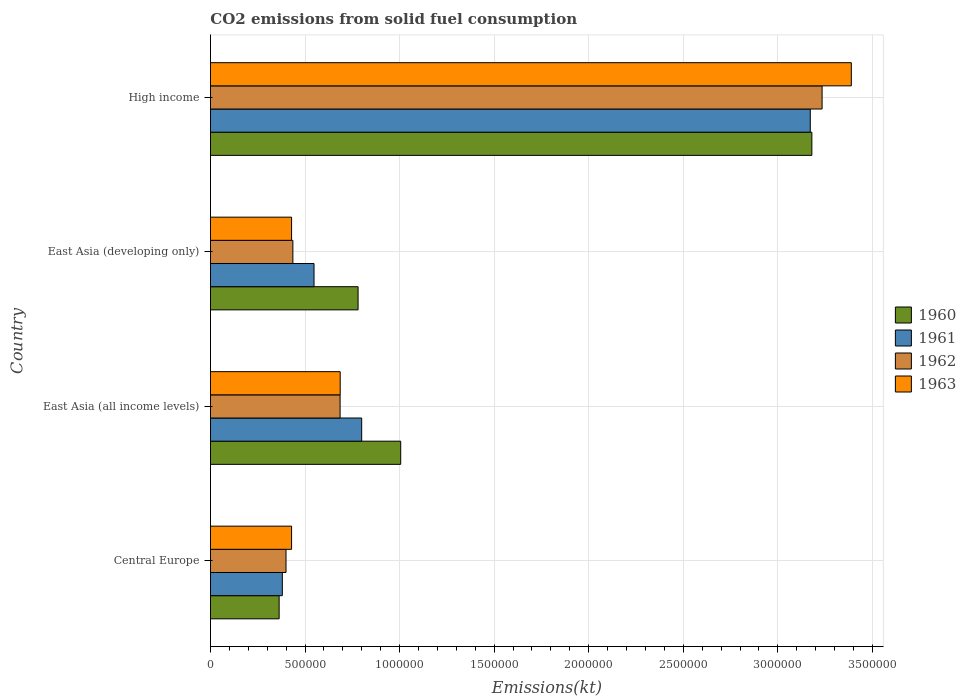Are the number of bars on each tick of the Y-axis equal?
Offer a very short reply. Yes. How many bars are there on the 4th tick from the bottom?
Provide a short and direct response. 4. What is the label of the 1st group of bars from the top?
Provide a short and direct response. High income. What is the amount of CO2 emitted in 1961 in Central Europe?
Provide a succinct answer. 3.80e+05. Across all countries, what is the maximum amount of CO2 emitted in 1961?
Your answer should be very brief. 3.17e+06. Across all countries, what is the minimum amount of CO2 emitted in 1963?
Offer a very short reply. 4.29e+05. In which country was the amount of CO2 emitted in 1960 minimum?
Your response must be concise. Central Europe. What is the total amount of CO2 emitted in 1963 in the graph?
Make the answer very short. 4.93e+06. What is the difference between the amount of CO2 emitted in 1961 in Central Europe and that in East Asia (developing only)?
Your response must be concise. -1.68e+05. What is the difference between the amount of CO2 emitted in 1961 in Central Europe and the amount of CO2 emitted in 1963 in East Asia (all income levels)?
Your response must be concise. -3.06e+05. What is the average amount of CO2 emitted in 1961 per country?
Your answer should be very brief. 1.22e+06. What is the difference between the amount of CO2 emitted in 1963 and amount of CO2 emitted in 1960 in High income?
Offer a terse response. 2.09e+05. What is the ratio of the amount of CO2 emitted in 1961 in Central Europe to that in East Asia (developing only)?
Ensure brevity in your answer.  0.69. Is the difference between the amount of CO2 emitted in 1963 in East Asia (all income levels) and High income greater than the difference between the amount of CO2 emitted in 1960 in East Asia (all income levels) and High income?
Offer a terse response. No. What is the difference between the highest and the second highest amount of CO2 emitted in 1962?
Provide a succinct answer. 2.55e+06. What is the difference between the highest and the lowest amount of CO2 emitted in 1960?
Provide a succinct answer. 2.82e+06. Is it the case that in every country, the sum of the amount of CO2 emitted in 1962 and amount of CO2 emitted in 1963 is greater than the sum of amount of CO2 emitted in 1960 and amount of CO2 emitted in 1961?
Your response must be concise. No. How many bars are there?
Provide a succinct answer. 16. How many countries are there in the graph?
Provide a short and direct response. 4. Does the graph contain grids?
Offer a terse response. Yes. How many legend labels are there?
Provide a short and direct response. 4. What is the title of the graph?
Provide a short and direct response. CO2 emissions from solid fuel consumption. Does "2004" appear as one of the legend labels in the graph?
Ensure brevity in your answer.  No. What is the label or title of the X-axis?
Provide a short and direct response. Emissions(kt). What is the label or title of the Y-axis?
Offer a very short reply. Country. What is the Emissions(kt) of 1960 in Central Europe?
Make the answer very short. 3.63e+05. What is the Emissions(kt) of 1961 in Central Europe?
Your answer should be compact. 3.80e+05. What is the Emissions(kt) in 1962 in Central Europe?
Your answer should be very brief. 3.99e+05. What is the Emissions(kt) of 1963 in Central Europe?
Ensure brevity in your answer.  4.29e+05. What is the Emissions(kt) of 1960 in East Asia (all income levels)?
Your answer should be compact. 1.01e+06. What is the Emissions(kt) of 1961 in East Asia (all income levels)?
Your answer should be compact. 8.00e+05. What is the Emissions(kt) in 1962 in East Asia (all income levels)?
Give a very brief answer. 6.85e+05. What is the Emissions(kt) of 1963 in East Asia (all income levels)?
Your answer should be very brief. 6.86e+05. What is the Emissions(kt) in 1960 in East Asia (developing only)?
Give a very brief answer. 7.80e+05. What is the Emissions(kt) in 1961 in East Asia (developing only)?
Your answer should be very brief. 5.48e+05. What is the Emissions(kt) of 1962 in East Asia (developing only)?
Offer a terse response. 4.36e+05. What is the Emissions(kt) in 1963 in East Asia (developing only)?
Your answer should be very brief. 4.29e+05. What is the Emissions(kt) in 1960 in High income?
Keep it short and to the point. 3.18e+06. What is the Emissions(kt) of 1961 in High income?
Provide a succinct answer. 3.17e+06. What is the Emissions(kt) of 1962 in High income?
Make the answer very short. 3.23e+06. What is the Emissions(kt) of 1963 in High income?
Keep it short and to the point. 3.39e+06. Across all countries, what is the maximum Emissions(kt) of 1960?
Give a very brief answer. 3.18e+06. Across all countries, what is the maximum Emissions(kt) in 1961?
Provide a succinct answer. 3.17e+06. Across all countries, what is the maximum Emissions(kt) of 1962?
Ensure brevity in your answer.  3.23e+06. Across all countries, what is the maximum Emissions(kt) of 1963?
Give a very brief answer. 3.39e+06. Across all countries, what is the minimum Emissions(kt) of 1960?
Your answer should be very brief. 3.63e+05. Across all countries, what is the minimum Emissions(kt) in 1961?
Provide a succinct answer. 3.80e+05. Across all countries, what is the minimum Emissions(kt) in 1962?
Make the answer very short. 3.99e+05. Across all countries, what is the minimum Emissions(kt) in 1963?
Your answer should be very brief. 4.29e+05. What is the total Emissions(kt) of 1960 in the graph?
Give a very brief answer. 5.33e+06. What is the total Emissions(kt) in 1961 in the graph?
Your answer should be compact. 4.90e+06. What is the total Emissions(kt) in 1962 in the graph?
Ensure brevity in your answer.  4.75e+06. What is the total Emissions(kt) in 1963 in the graph?
Ensure brevity in your answer.  4.93e+06. What is the difference between the Emissions(kt) in 1960 in Central Europe and that in East Asia (all income levels)?
Your answer should be very brief. -6.43e+05. What is the difference between the Emissions(kt) of 1961 in Central Europe and that in East Asia (all income levels)?
Offer a very short reply. -4.20e+05. What is the difference between the Emissions(kt) of 1962 in Central Europe and that in East Asia (all income levels)?
Ensure brevity in your answer.  -2.86e+05. What is the difference between the Emissions(kt) of 1963 in Central Europe and that in East Asia (all income levels)?
Make the answer very short. -2.57e+05. What is the difference between the Emissions(kt) in 1960 in Central Europe and that in East Asia (developing only)?
Ensure brevity in your answer.  -4.17e+05. What is the difference between the Emissions(kt) in 1961 in Central Europe and that in East Asia (developing only)?
Keep it short and to the point. -1.68e+05. What is the difference between the Emissions(kt) of 1962 in Central Europe and that in East Asia (developing only)?
Give a very brief answer. -3.63e+04. What is the difference between the Emissions(kt) of 1963 in Central Europe and that in East Asia (developing only)?
Ensure brevity in your answer.  4.63. What is the difference between the Emissions(kt) of 1960 in Central Europe and that in High income?
Keep it short and to the point. -2.82e+06. What is the difference between the Emissions(kt) in 1961 in Central Europe and that in High income?
Ensure brevity in your answer.  -2.79e+06. What is the difference between the Emissions(kt) in 1962 in Central Europe and that in High income?
Make the answer very short. -2.83e+06. What is the difference between the Emissions(kt) of 1963 in Central Europe and that in High income?
Offer a terse response. -2.96e+06. What is the difference between the Emissions(kt) in 1960 in East Asia (all income levels) and that in East Asia (developing only)?
Provide a succinct answer. 2.25e+05. What is the difference between the Emissions(kt) in 1961 in East Asia (all income levels) and that in East Asia (developing only)?
Your answer should be compact. 2.52e+05. What is the difference between the Emissions(kt) in 1962 in East Asia (all income levels) and that in East Asia (developing only)?
Provide a succinct answer. 2.50e+05. What is the difference between the Emissions(kt) of 1963 in East Asia (all income levels) and that in East Asia (developing only)?
Provide a short and direct response. 2.57e+05. What is the difference between the Emissions(kt) of 1960 in East Asia (all income levels) and that in High income?
Keep it short and to the point. -2.17e+06. What is the difference between the Emissions(kt) of 1961 in East Asia (all income levels) and that in High income?
Give a very brief answer. -2.37e+06. What is the difference between the Emissions(kt) in 1962 in East Asia (all income levels) and that in High income?
Give a very brief answer. -2.55e+06. What is the difference between the Emissions(kt) in 1963 in East Asia (all income levels) and that in High income?
Provide a short and direct response. -2.70e+06. What is the difference between the Emissions(kt) in 1960 in East Asia (developing only) and that in High income?
Provide a short and direct response. -2.40e+06. What is the difference between the Emissions(kt) in 1961 in East Asia (developing only) and that in High income?
Offer a very short reply. -2.62e+06. What is the difference between the Emissions(kt) of 1962 in East Asia (developing only) and that in High income?
Your response must be concise. -2.80e+06. What is the difference between the Emissions(kt) in 1963 in East Asia (developing only) and that in High income?
Ensure brevity in your answer.  -2.96e+06. What is the difference between the Emissions(kt) of 1960 in Central Europe and the Emissions(kt) of 1961 in East Asia (all income levels)?
Make the answer very short. -4.36e+05. What is the difference between the Emissions(kt) in 1960 in Central Europe and the Emissions(kt) in 1962 in East Asia (all income levels)?
Make the answer very short. -3.22e+05. What is the difference between the Emissions(kt) in 1960 in Central Europe and the Emissions(kt) in 1963 in East Asia (all income levels)?
Your answer should be compact. -3.23e+05. What is the difference between the Emissions(kt) in 1961 in Central Europe and the Emissions(kt) in 1962 in East Asia (all income levels)?
Give a very brief answer. -3.05e+05. What is the difference between the Emissions(kt) in 1961 in Central Europe and the Emissions(kt) in 1963 in East Asia (all income levels)?
Offer a terse response. -3.06e+05. What is the difference between the Emissions(kt) of 1962 in Central Europe and the Emissions(kt) of 1963 in East Asia (all income levels)?
Provide a succinct answer. -2.86e+05. What is the difference between the Emissions(kt) in 1960 in Central Europe and the Emissions(kt) in 1961 in East Asia (developing only)?
Provide a succinct answer. -1.84e+05. What is the difference between the Emissions(kt) of 1960 in Central Europe and the Emissions(kt) of 1962 in East Asia (developing only)?
Your answer should be compact. -7.27e+04. What is the difference between the Emissions(kt) of 1960 in Central Europe and the Emissions(kt) of 1963 in East Asia (developing only)?
Provide a short and direct response. -6.58e+04. What is the difference between the Emissions(kt) of 1961 in Central Europe and the Emissions(kt) of 1962 in East Asia (developing only)?
Provide a short and direct response. -5.58e+04. What is the difference between the Emissions(kt) in 1961 in Central Europe and the Emissions(kt) in 1963 in East Asia (developing only)?
Your answer should be very brief. -4.89e+04. What is the difference between the Emissions(kt) of 1962 in Central Europe and the Emissions(kt) of 1963 in East Asia (developing only)?
Offer a terse response. -2.94e+04. What is the difference between the Emissions(kt) in 1960 in Central Europe and the Emissions(kt) in 1961 in High income?
Offer a terse response. -2.81e+06. What is the difference between the Emissions(kt) in 1960 in Central Europe and the Emissions(kt) in 1962 in High income?
Provide a succinct answer. -2.87e+06. What is the difference between the Emissions(kt) of 1960 in Central Europe and the Emissions(kt) of 1963 in High income?
Ensure brevity in your answer.  -3.03e+06. What is the difference between the Emissions(kt) in 1961 in Central Europe and the Emissions(kt) in 1962 in High income?
Offer a terse response. -2.85e+06. What is the difference between the Emissions(kt) in 1961 in Central Europe and the Emissions(kt) in 1963 in High income?
Your answer should be very brief. -3.01e+06. What is the difference between the Emissions(kt) in 1962 in Central Europe and the Emissions(kt) in 1963 in High income?
Your response must be concise. -2.99e+06. What is the difference between the Emissions(kt) in 1960 in East Asia (all income levels) and the Emissions(kt) in 1961 in East Asia (developing only)?
Your answer should be compact. 4.58e+05. What is the difference between the Emissions(kt) in 1960 in East Asia (all income levels) and the Emissions(kt) in 1962 in East Asia (developing only)?
Your response must be concise. 5.70e+05. What is the difference between the Emissions(kt) of 1960 in East Asia (all income levels) and the Emissions(kt) of 1963 in East Asia (developing only)?
Ensure brevity in your answer.  5.77e+05. What is the difference between the Emissions(kt) in 1961 in East Asia (all income levels) and the Emissions(kt) in 1962 in East Asia (developing only)?
Keep it short and to the point. 3.64e+05. What is the difference between the Emissions(kt) in 1961 in East Asia (all income levels) and the Emissions(kt) in 1963 in East Asia (developing only)?
Offer a terse response. 3.71e+05. What is the difference between the Emissions(kt) in 1962 in East Asia (all income levels) and the Emissions(kt) in 1963 in East Asia (developing only)?
Give a very brief answer. 2.57e+05. What is the difference between the Emissions(kt) of 1960 in East Asia (all income levels) and the Emissions(kt) of 1961 in High income?
Offer a terse response. -2.17e+06. What is the difference between the Emissions(kt) of 1960 in East Asia (all income levels) and the Emissions(kt) of 1962 in High income?
Your answer should be compact. -2.23e+06. What is the difference between the Emissions(kt) of 1960 in East Asia (all income levels) and the Emissions(kt) of 1963 in High income?
Your answer should be compact. -2.38e+06. What is the difference between the Emissions(kt) in 1961 in East Asia (all income levels) and the Emissions(kt) in 1962 in High income?
Keep it short and to the point. -2.43e+06. What is the difference between the Emissions(kt) in 1961 in East Asia (all income levels) and the Emissions(kt) in 1963 in High income?
Make the answer very short. -2.59e+06. What is the difference between the Emissions(kt) of 1962 in East Asia (all income levels) and the Emissions(kt) of 1963 in High income?
Your answer should be compact. -2.70e+06. What is the difference between the Emissions(kt) in 1960 in East Asia (developing only) and the Emissions(kt) in 1961 in High income?
Give a very brief answer. -2.39e+06. What is the difference between the Emissions(kt) in 1960 in East Asia (developing only) and the Emissions(kt) in 1962 in High income?
Your answer should be compact. -2.45e+06. What is the difference between the Emissions(kt) in 1960 in East Asia (developing only) and the Emissions(kt) in 1963 in High income?
Keep it short and to the point. -2.61e+06. What is the difference between the Emissions(kt) in 1961 in East Asia (developing only) and the Emissions(kt) in 1962 in High income?
Your answer should be compact. -2.69e+06. What is the difference between the Emissions(kt) of 1961 in East Asia (developing only) and the Emissions(kt) of 1963 in High income?
Your answer should be compact. -2.84e+06. What is the difference between the Emissions(kt) in 1962 in East Asia (developing only) and the Emissions(kt) in 1963 in High income?
Your answer should be very brief. -2.95e+06. What is the average Emissions(kt) of 1960 per country?
Ensure brevity in your answer.  1.33e+06. What is the average Emissions(kt) in 1961 per country?
Make the answer very short. 1.22e+06. What is the average Emissions(kt) in 1962 per country?
Give a very brief answer. 1.19e+06. What is the average Emissions(kt) of 1963 per country?
Make the answer very short. 1.23e+06. What is the difference between the Emissions(kt) in 1960 and Emissions(kt) in 1961 in Central Europe?
Provide a succinct answer. -1.68e+04. What is the difference between the Emissions(kt) of 1960 and Emissions(kt) of 1962 in Central Europe?
Provide a succinct answer. -3.64e+04. What is the difference between the Emissions(kt) of 1960 and Emissions(kt) of 1963 in Central Europe?
Offer a terse response. -6.58e+04. What is the difference between the Emissions(kt) in 1961 and Emissions(kt) in 1962 in Central Europe?
Keep it short and to the point. -1.96e+04. What is the difference between the Emissions(kt) of 1961 and Emissions(kt) of 1963 in Central Europe?
Your answer should be compact. -4.89e+04. What is the difference between the Emissions(kt) of 1962 and Emissions(kt) of 1963 in Central Europe?
Provide a short and direct response. -2.94e+04. What is the difference between the Emissions(kt) in 1960 and Emissions(kt) in 1961 in East Asia (all income levels)?
Give a very brief answer. 2.06e+05. What is the difference between the Emissions(kt) of 1960 and Emissions(kt) of 1962 in East Asia (all income levels)?
Your response must be concise. 3.20e+05. What is the difference between the Emissions(kt) in 1960 and Emissions(kt) in 1963 in East Asia (all income levels)?
Your response must be concise. 3.20e+05. What is the difference between the Emissions(kt) in 1961 and Emissions(kt) in 1962 in East Asia (all income levels)?
Provide a short and direct response. 1.14e+05. What is the difference between the Emissions(kt) in 1961 and Emissions(kt) in 1963 in East Asia (all income levels)?
Keep it short and to the point. 1.14e+05. What is the difference between the Emissions(kt) in 1962 and Emissions(kt) in 1963 in East Asia (all income levels)?
Your answer should be very brief. -517.54. What is the difference between the Emissions(kt) in 1960 and Emissions(kt) in 1961 in East Asia (developing only)?
Offer a terse response. 2.33e+05. What is the difference between the Emissions(kt) in 1960 and Emissions(kt) in 1962 in East Asia (developing only)?
Provide a short and direct response. 3.45e+05. What is the difference between the Emissions(kt) of 1960 and Emissions(kt) of 1963 in East Asia (developing only)?
Offer a very short reply. 3.52e+05. What is the difference between the Emissions(kt) of 1961 and Emissions(kt) of 1962 in East Asia (developing only)?
Your answer should be compact. 1.12e+05. What is the difference between the Emissions(kt) of 1961 and Emissions(kt) of 1963 in East Asia (developing only)?
Make the answer very short. 1.19e+05. What is the difference between the Emissions(kt) of 1962 and Emissions(kt) of 1963 in East Asia (developing only)?
Your answer should be very brief. 6890.94. What is the difference between the Emissions(kt) of 1960 and Emissions(kt) of 1961 in High income?
Your answer should be compact. 8354.42. What is the difference between the Emissions(kt) of 1960 and Emissions(kt) of 1962 in High income?
Keep it short and to the point. -5.41e+04. What is the difference between the Emissions(kt) in 1960 and Emissions(kt) in 1963 in High income?
Provide a succinct answer. -2.09e+05. What is the difference between the Emissions(kt) in 1961 and Emissions(kt) in 1962 in High income?
Give a very brief answer. -6.24e+04. What is the difference between the Emissions(kt) in 1961 and Emissions(kt) in 1963 in High income?
Ensure brevity in your answer.  -2.17e+05. What is the difference between the Emissions(kt) of 1962 and Emissions(kt) of 1963 in High income?
Offer a very short reply. -1.55e+05. What is the ratio of the Emissions(kt) of 1960 in Central Europe to that in East Asia (all income levels)?
Make the answer very short. 0.36. What is the ratio of the Emissions(kt) in 1961 in Central Europe to that in East Asia (all income levels)?
Provide a succinct answer. 0.48. What is the ratio of the Emissions(kt) of 1962 in Central Europe to that in East Asia (all income levels)?
Your response must be concise. 0.58. What is the ratio of the Emissions(kt) of 1963 in Central Europe to that in East Asia (all income levels)?
Give a very brief answer. 0.63. What is the ratio of the Emissions(kt) of 1960 in Central Europe to that in East Asia (developing only)?
Keep it short and to the point. 0.47. What is the ratio of the Emissions(kt) in 1961 in Central Europe to that in East Asia (developing only)?
Offer a terse response. 0.69. What is the ratio of the Emissions(kt) of 1962 in Central Europe to that in East Asia (developing only)?
Make the answer very short. 0.92. What is the ratio of the Emissions(kt) in 1963 in Central Europe to that in East Asia (developing only)?
Ensure brevity in your answer.  1. What is the ratio of the Emissions(kt) in 1960 in Central Europe to that in High income?
Give a very brief answer. 0.11. What is the ratio of the Emissions(kt) of 1961 in Central Europe to that in High income?
Keep it short and to the point. 0.12. What is the ratio of the Emissions(kt) in 1962 in Central Europe to that in High income?
Your answer should be very brief. 0.12. What is the ratio of the Emissions(kt) in 1963 in Central Europe to that in High income?
Ensure brevity in your answer.  0.13. What is the ratio of the Emissions(kt) in 1960 in East Asia (all income levels) to that in East Asia (developing only)?
Provide a succinct answer. 1.29. What is the ratio of the Emissions(kt) in 1961 in East Asia (all income levels) to that in East Asia (developing only)?
Your response must be concise. 1.46. What is the ratio of the Emissions(kt) in 1962 in East Asia (all income levels) to that in East Asia (developing only)?
Offer a terse response. 1.57. What is the ratio of the Emissions(kt) of 1963 in East Asia (all income levels) to that in East Asia (developing only)?
Your answer should be very brief. 1.6. What is the ratio of the Emissions(kt) in 1960 in East Asia (all income levels) to that in High income?
Make the answer very short. 0.32. What is the ratio of the Emissions(kt) of 1961 in East Asia (all income levels) to that in High income?
Your answer should be very brief. 0.25. What is the ratio of the Emissions(kt) in 1962 in East Asia (all income levels) to that in High income?
Provide a short and direct response. 0.21. What is the ratio of the Emissions(kt) in 1963 in East Asia (all income levels) to that in High income?
Your answer should be compact. 0.2. What is the ratio of the Emissions(kt) of 1960 in East Asia (developing only) to that in High income?
Offer a very short reply. 0.25. What is the ratio of the Emissions(kt) in 1961 in East Asia (developing only) to that in High income?
Keep it short and to the point. 0.17. What is the ratio of the Emissions(kt) in 1962 in East Asia (developing only) to that in High income?
Provide a succinct answer. 0.13. What is the ratio of the Emissions(kt) in 1963 in East Asia (developing only) to that in High income?
Ensure brevity in your answer.  0.13. What is the difference between the highest and the second highest Emissions(kt) in 1960?
Your answer should be compact. 2.17e+06. What is the difference between the highest and the second highest Emissions(kt) in 1961?
Provide a short and direct response. 2.37e+06. What is the difference between the highest and the second highest Emissions(kt) of 1962?
Give a very brief answer. 2.55e+06. What is the difference between the highest and the second highest Emissions(kt) in 1963?
Your answer should be compact. 2.70e+06. What is the difference between the highest and the lowest Emissions(kt) of 1960?
Provide a succinct answer. 2.82e+06. What is the difference between the highest and the lowest Emissions(kt) of 1961?
Your response must be concise. 2.79e+06. What is the difference between the highest and the lowest Emissions(kt) in 1962?
Offer a very short reply. 2.83e+06. What is the difference between the highest and the lowest Emissions(kt) in 1963?
Your answer should be very brief. 2.96e+06. 